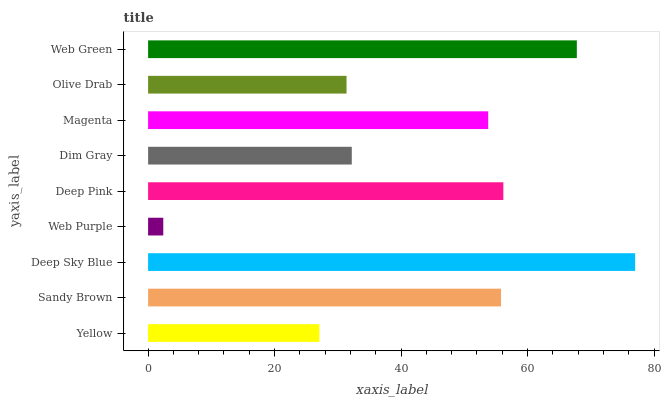Is Web Purple the minimum?
Answer yes or no. Yes. Is Deep Sky Blue the maximum?
Answer yes or no. Yes. Is Sandy Brown the minimum?
Answer yes or no. No. Is Sandy Brown the maximum?
Answer yes or no. No. Is Sandy Brown greater than Yellow?
Answer yes or no. Yes. Is Yellow less than Sandy Brown?
Answer yes or no. Yes. Is Yellow greater than Sandy Brown?
Answer yes or no. No. Is Sandy Brown less than Yellow?
Answer yes or no. No. Is Magenta the high median?
Answer yes or no. Yes. Is Magenta the low median?
Answer yes or no. Yes. Is Web Purple the high median?
Answer yes or no. No. Is Web Purple the low median?
Answer yes or no. No. 